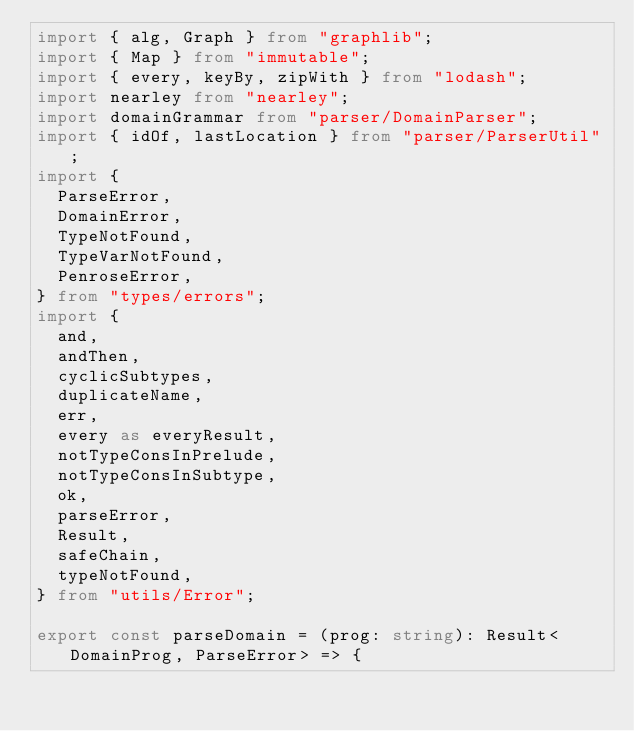<code> <loc_0><loc_0><loc_500><loc_500><_TypeScript_>import { alg, Graph } from "graphlib";
import { Map } from "immutable";
import { every, keyBy, zipWith } from "lodash";
import nearley from "nearley";
import domainGrammar from "parser/DomainParser";
import { idOf, lastLocation } from "parser/ParserUtil";
import {
  ParseError,
  DomainError,
  TypeNotFound,
  TypeVarNotFound,
  PenroseError,
} from "types/errors";
import {
  and,
  andThen,
  cyclicSubtypes,
  duplicateName,
  err,
  every as everyResult,
  notTypeConsInPrelude,
  notTypeConsInSubtype,
  ok,
  parseError,
  Result,
  safeChain,
  typeNotFound,
} from "utils/Error";

export const parseDomain = (prog: string): Result<DomainProg, ParseError> => {</code> 